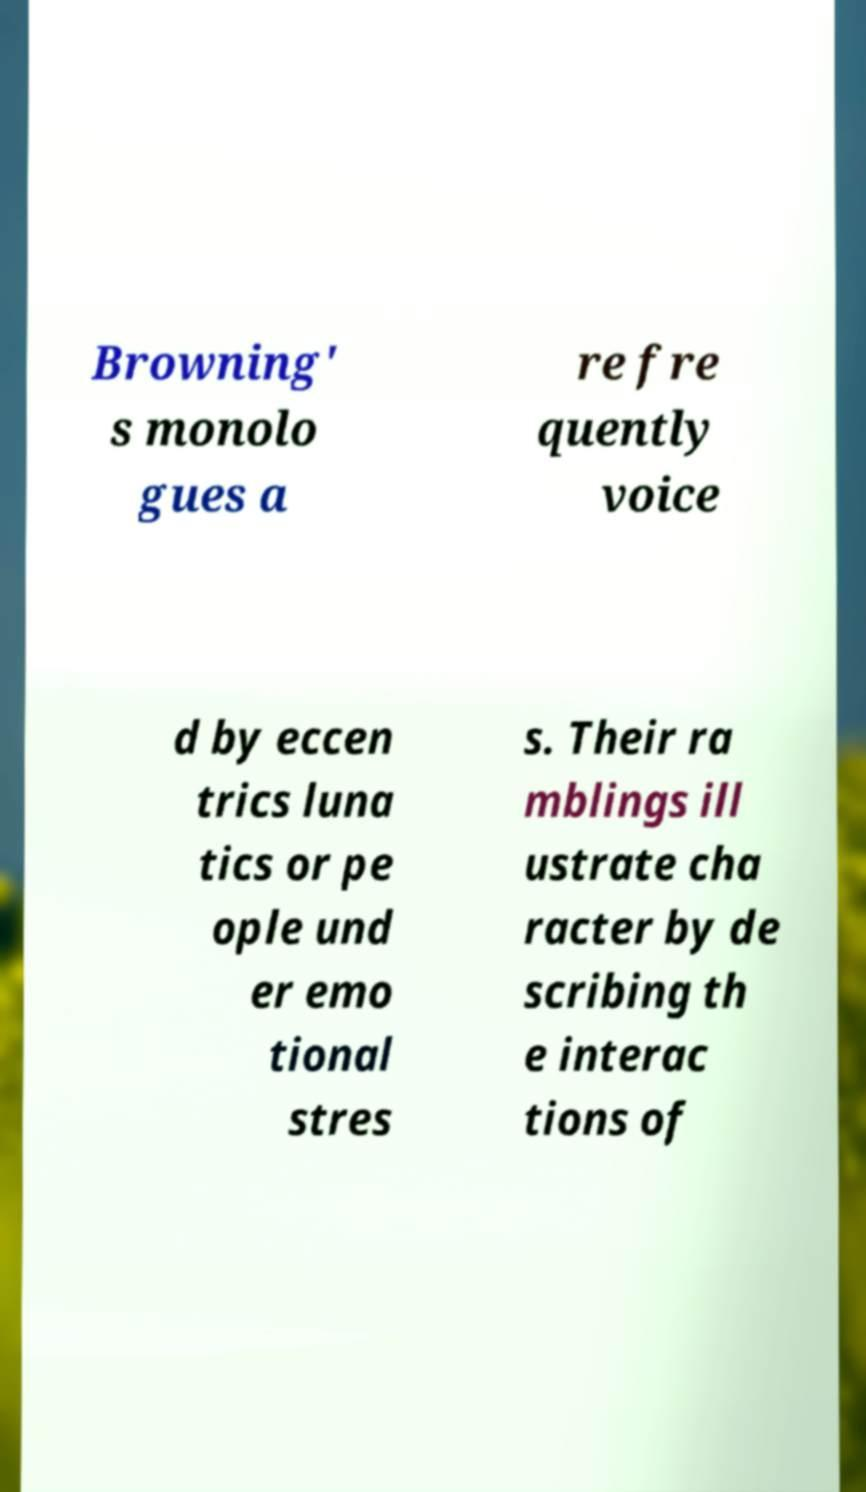Could you extract and type out the text from this image? Browning' s monolo gues a re fre quently voice d by eccen trics luna tics or pe ople und er emo tional stres s. Their ra mblings ill ustrate cha racter by de scribing th e interac tions of 